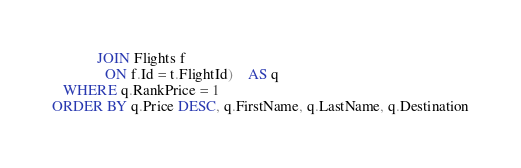Convert code to text. <code><loc_0><loc_0><loc_500><loc_500><_SQL_>			JOIN Flights f
			  ON f.Id = t.FlightId)	AS q
   WHERE q.RankPrice = 1
ORDER BY q.Price DESC, q.FirstName, q.LastName, q.Destination</code> 